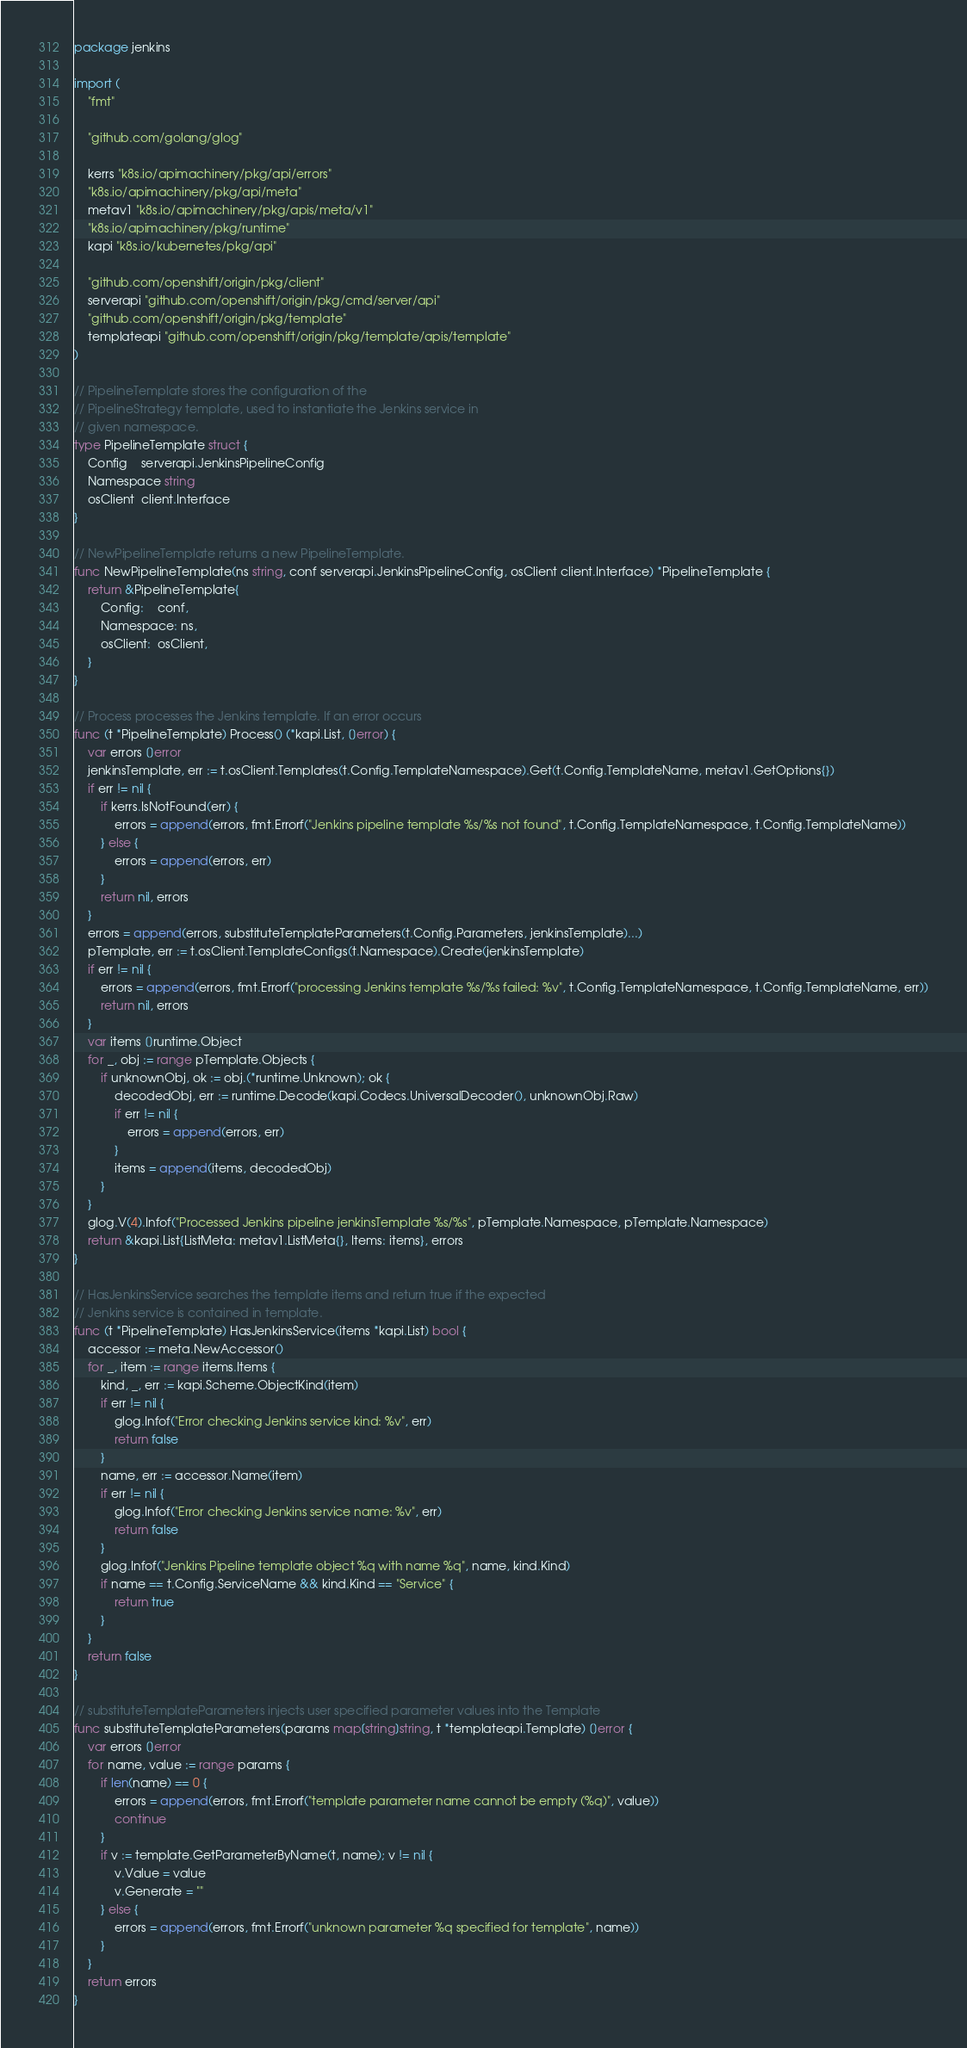Convert code to text. <code><loc_0><loc_0><loc_500><loc_500><_Go_>package jenkins

import (
	"fmt"

	"github.com/golang/glog"

	kerrs "k8s.io/apimachinery/pkg/api/errors"
	"k8s.io/apimachinery/pkg/api/meta"
	metav1 "k8s.io/apimachinery/pkg/apis/meta/v1"
	"k8s.io/apimachinery/pkg/runtime"
	kapi "k8s.io/kubernetes/pkg/api"

	"github.com/openshift/origin/pkg/client"
	serverapi "github.com/openshift/origin/pkg/cmd/server/api"
	"github.com/openshift/origin/pkg/template"
	templateapi "github.com/openshift/origin/pkg/template/apis/template"
)

// PipelineTemplate stores the configuration of the
// PipelineStrategy template, used to instantiate the Jenkins service in
// given namespace.
type PipelineTemplate struct {
	Config    serverapi.JenkinsPipelineConfig
	Namespace string
	osClient  client.Interface
}

// NewPipelineTemplate returns a new PipelineTemplate.
func NewPipelineTemplate(ns string, conf serverapi.JenkinsPipelineConfig, osClient client.Interface) *PipelineTemplate {
	return &PipelineTemplate{
		Config:    conf,
		Namespace: ns,
		osClient:  osClient,
	}
}

// Process processes the Jenkins template. If an error occurs
func (t *PipelineTemplate) Process() (*kapi.List, []error) {
	var errors []error
	jenkinsTemplate, err := t.osClient.Templates(t.Config.TemplateNamespace).Get(t.Config.TemplateName, metav1.GetOptions{})
	if err != nil {
		if kerrs.IsNotFound(err) {
			errors = append(errors, fmt.Errorf("Jenkins pipeline template %s/%s not found", t.Config.TemplateNamespace, t.Config.TemplateName))
		} else {
			errors = append(errors, err)
		}
		return nil, errors
	}
	errors = append(errors, substituteTemplateParameters(t.Config.Parameters, jenkinsTemplate)...)
	pTemplate, err := t.osClient.TemplateConfigs(t.Namespace).Create(jenkinsTemplate)
	if err != nil {
		errors = append(errors, fmt.Errorf("processing Jenkins template %s/%s failed: %v", t.Config.TemplateNamespace, t.Config.TemplateName, err))
		return nil, errors
	}
	var items []runtime.Object
	for _, obj := range pTemplate.Objects {
		if unknownObj, ok := obj.(*runtime.Unknown); ok {
			decodedObj, err := runtime.Decode(kapi.Codecs.UniversalDecoder(), unknownObj.Raw)
			if err != nil {
				errors = append(errors, err)
			}
			items = append(items, decodedObj)
		}
	}
	glog.V(4).Infof("Processed Jenkins pipeline jenkinsTemplate %s/%s", pTemplate.Namespace, pTemplate.Namespace)
	return &kapi.List{ListMeta: metav1.ListMeta{}, Items: items}, errors
}

// HasJenkinsService searches the template items and return true if the expected
// Jenkins service is contained in template.
func (t *PipelineTemplate) HasJenkinsService(items *kapi.List) bool {
	accessor := meta.NewAccessor()
	for _, item := range items.Items {
		kind, _, err := kapi.Scheme.ObjectKind(item)
		if err != nil {
			glog.Infof("Error checking Jenkins service kind: %v", err)
			return false
		}
		name, err := accessor.Name(item)
		if err != nil {
			glog.Infof("Error checking Jenkins service name: %v", err)
			return false
		}
		glog.Infof("Jenkins Pipeline template object %q with name %q", name, kind.Kind)
		if name == t.Config.ServiceName && kind.Kind == "Service" {
			return true
		}
	}
	return false
}

// substituteTemplateParameters injects user specified parameter values into the Template
func substituteTemplateParameters(params map[string]string, t *templateapi.Template) []error {
	var errors []error
	for name, value := range params {
		if len(name) == 0 {
			errors = append(errors, fmt.Errorf("template parameter name cannot be empty (%q)", value))
			continue
		}
		if v := template.GetParameterByName(t, name); v != nil {
			v.Value = value
			v.Generate = ""
		} else {
			errors = append(errors, fmt.Errorf("unknown parameter %q specified for template", name))
		}
	}
	return errors
}
</code> 